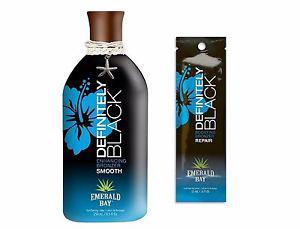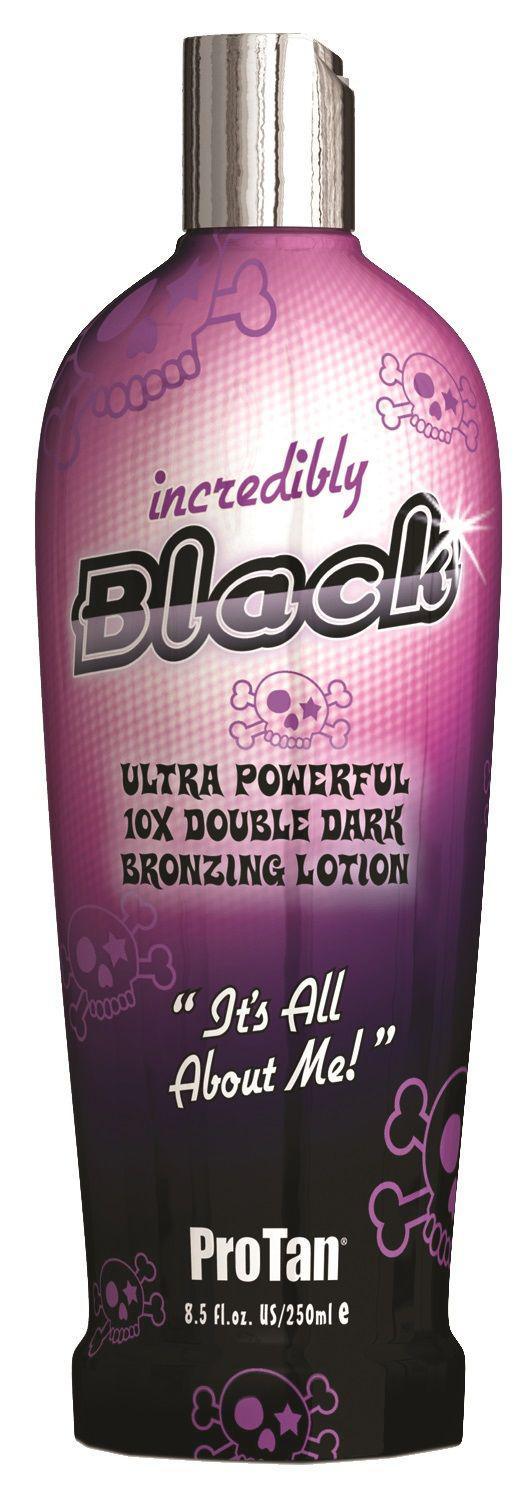The first image is the image on the left, the second image is the image on the right. Analyze the images presented: Is the assertion "The image to the right features nothing more than one single bottle." valid? Answer yes or no. Yes. The first image is the image on the left, the second image is the image on the right. Considering the images on both sides, is "there is no more then three items" valid? Answer yes or no. Yes. 